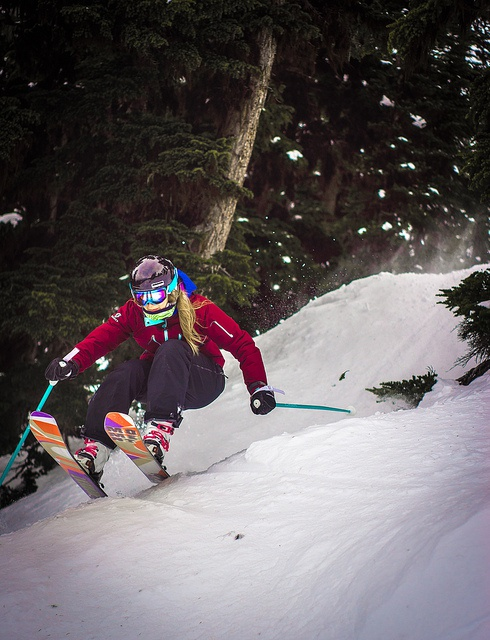Describe the objects in this image and their specific colors. I can see people in black, maroon, brown, and purple tones and skis in black, gray, tan, red, and darkgray tones in this image. 